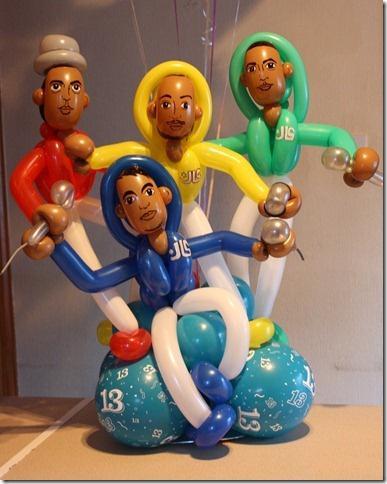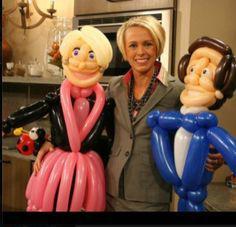The first image is the image on the left, the second image is the image on the right. For the images shown, is this caption "In at least one image there are at least six pink ballons making a skirt." true? Answer yes or no. Yes. The first image is the image on the left, the second image is the image on the right. For the images shown, is this caption "The right and left images contain human figures made out of balloons, and one image includes a blond balloon woman wearing a pink skirt." true? Answer yes or no. Yes. 